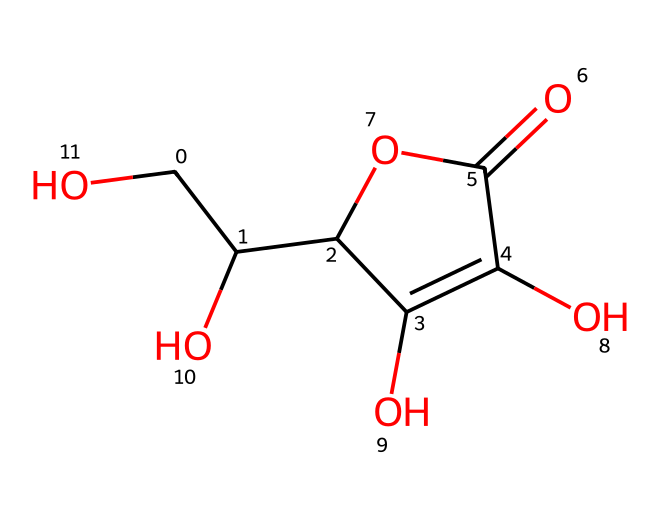how many carbon atoms are in ascorbic acid? By analyzing the SMILES representation, we can count the 'C' characters that indicate carbon atoms. In this case, there are six 'C' characters present in the structure.
Answer: six what is the main functional group in ascorbic acid? In the chemical structure represented by the SMILES, the presence of the -OH groups indicates that hydroxyl is a significant functional group. Additionally, the -C(=O)O functional group shows it also contains a carboxylic acid. The predominant group is the hydroxyl, contributing significantly to the properties of ascorbic acid.
Answer: hydroxyl what type of molecule is ascorbic acid classified as? Ascorbic acid contains multiple hydroxyl (-OH) groups and a ketone, which classifies it as a vitamin, specifically a water-soluble vitamin, due to its solubility in water and its biological role.
Answer: vitamin which configuration of carbon is present in ascorbic acid? In the structure, we see that there are multiple chiral centers based on the arrangement of substituents around certain carbon atoms. Chiral centers are typically where four different groups are attached to a carbon atom. In ascorbic acid, two of the carbon atoms are chiral.
Answer: chiral what is the molecular formula for ascorbic acid according to its structure? From counting the different atoms represented in the SMILES, we have six carbons, eight hydrogens, and six oxygens. This leads to the molecular formula C6H8O6 for ascorbic acid.
Answer: C6H8O6 does ascorbic acid contain any double bonds? The double bond in this structure can be seen in the carbonyl group (C=O) which is part of the carboxylic acid group present in the compound. Therefore, there is at least one double bond in ascorbic acid.
Answer: yes 